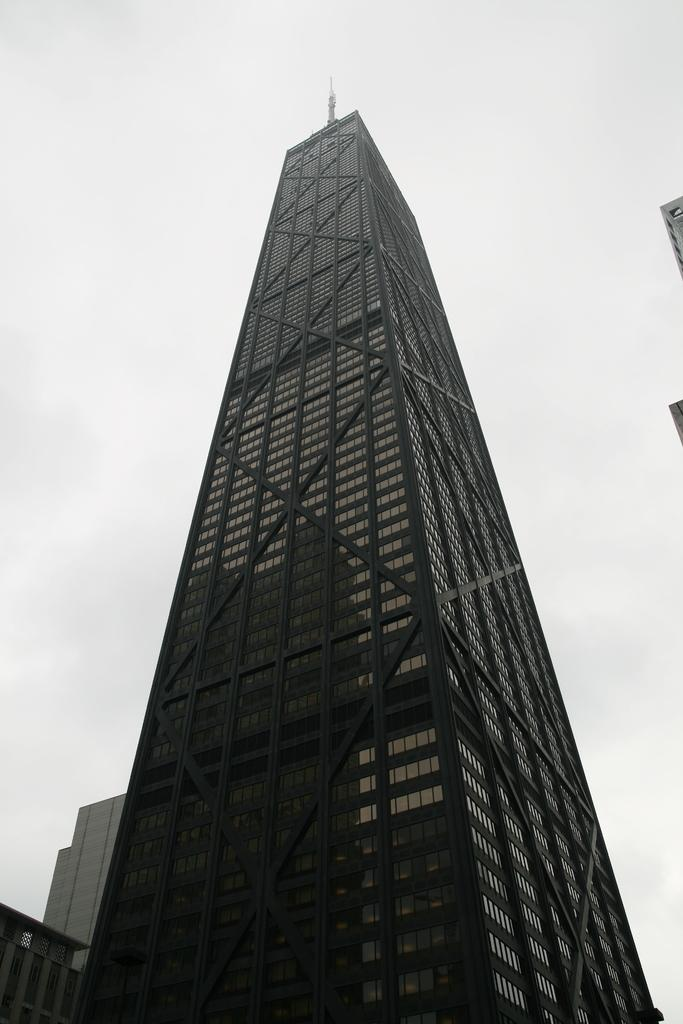What type of building is the main focus of the image? There is a tower building with black colored glasses in the image. Are there any other buildings in the image? Yes, there are other buildings beside the tower building. What can be seen behind the tower building? The sky is visible behind the tower building. Are there any plants growing on the tower building in the image? There is no mention of plants growing on the tower building in the image. 